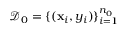<formula> <loc_0><loc_0><loc_500><loc_500>\mathcal { D } _ { 0 } = \{ ( x _ { i } , y _ { i } ) \} _ { i = 1 } ^ { n _ { 0 } }</formula> 